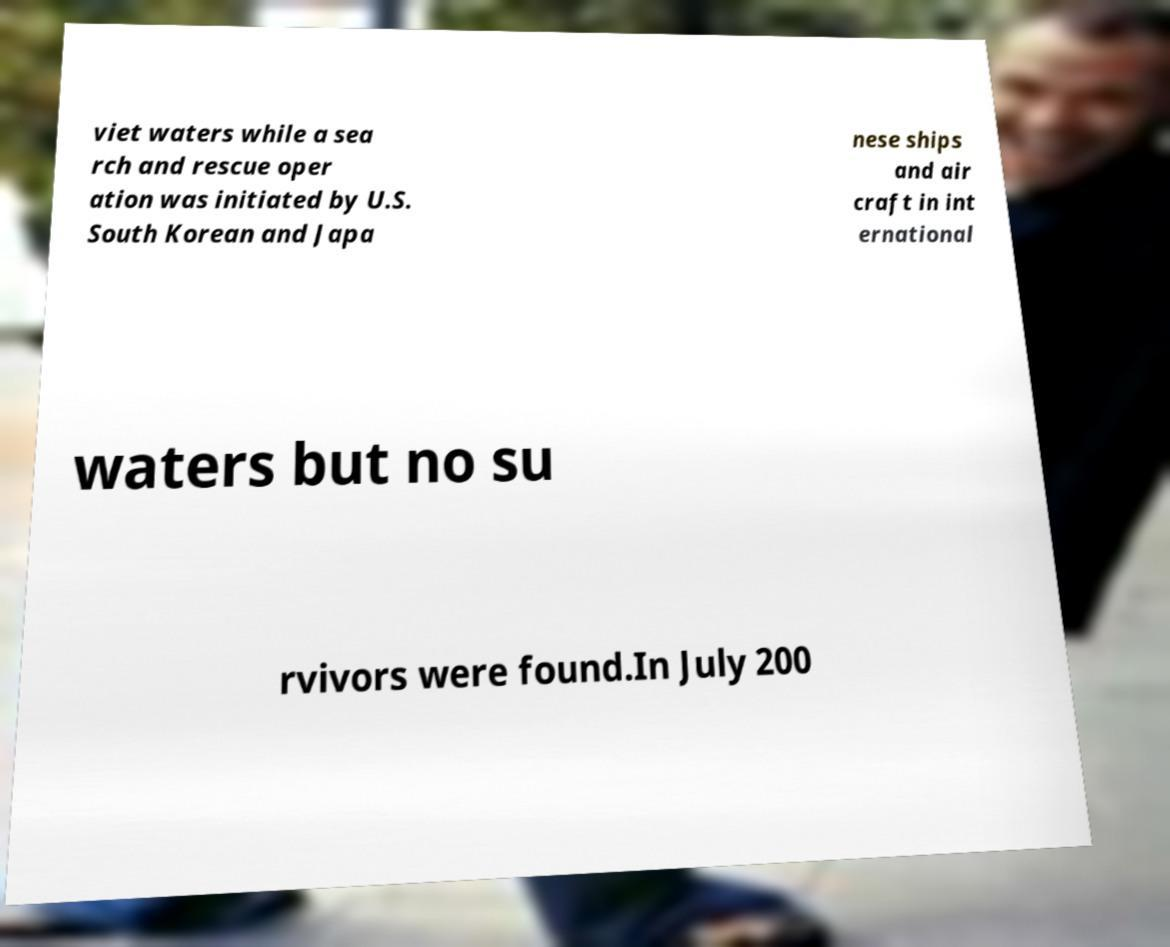I need the written content from this picture converted into text. Can you do that? viet waters while a sea rch and rescue oper ation was initiated by U.S. South Korean and Japa nese ships and air craft in int ernational waters but no su rvivors were found.In July 200 